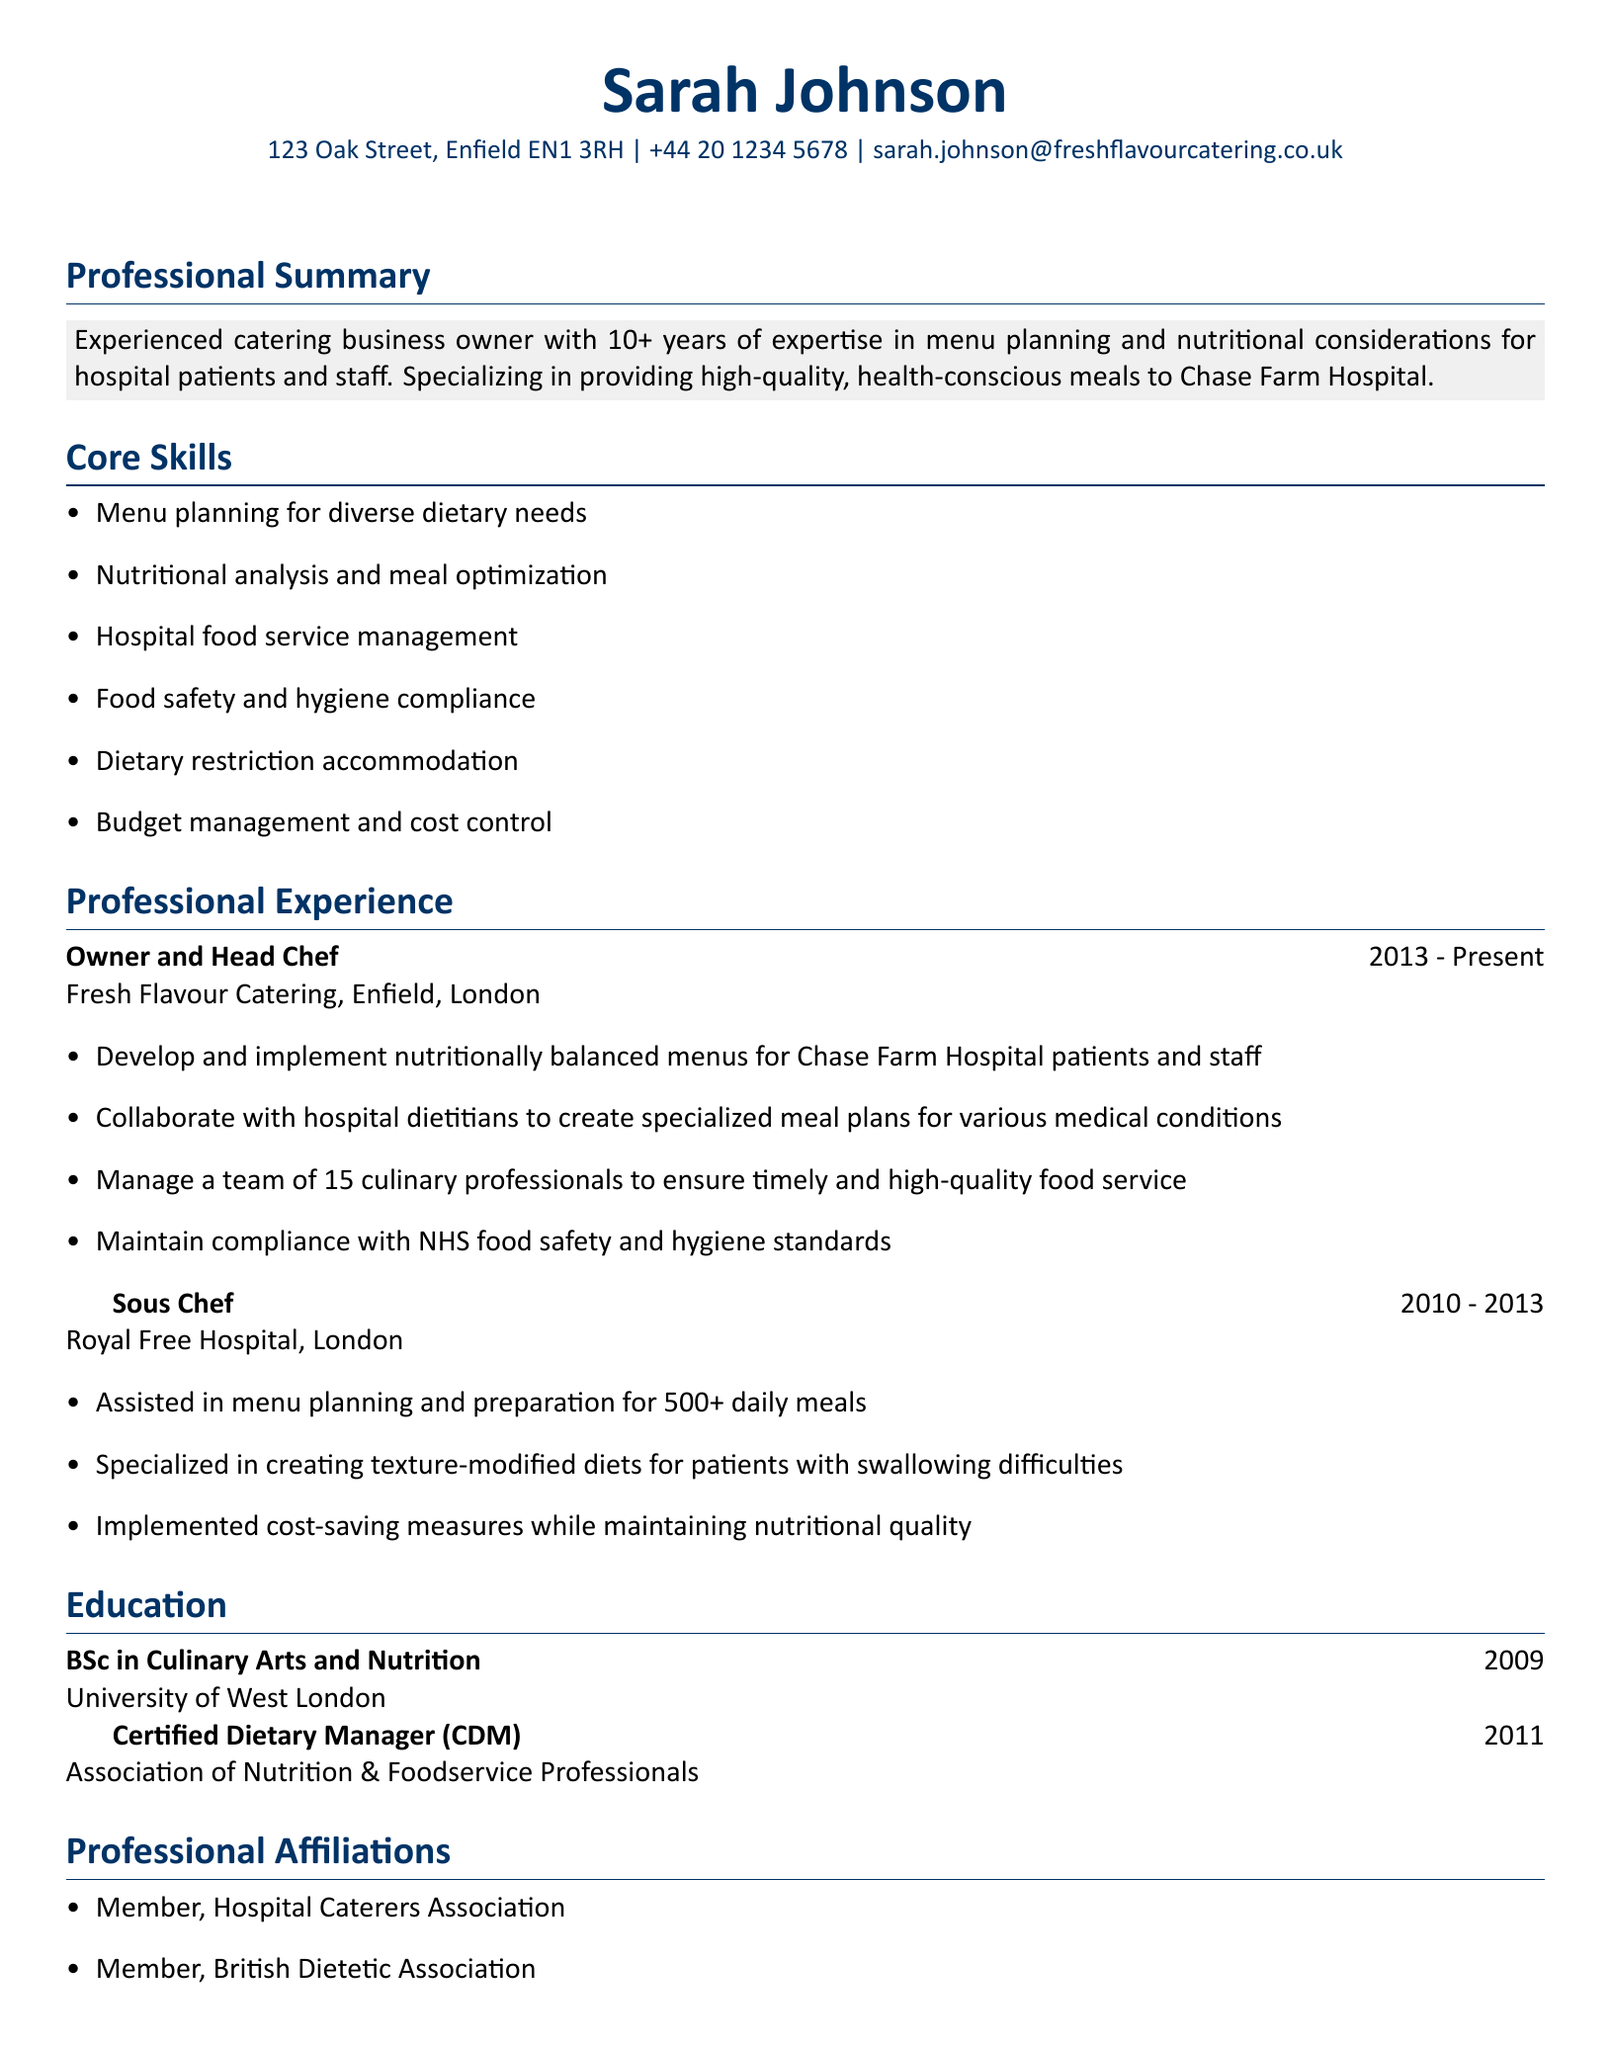What is the name of the business owner? The name of the business owner is listed at the top of the document as Sarah Johnson.
Answer: Sarah Johnson What is Sarah Johnson's email address? The email address is provided in the personal information section of the CV.
Answer: sarah.johnson@freshflavourcatering.co.uk How many years of experience does Sarah Johnson have? The professional summary mentions that she has 10+ years of experience in catering.
Answer: 10+ In which year did Sarah Johnson obtain her degree? The education section states the year she completed her degree in Culinary Arts and Nutrition.
Answer: 2009 What position did Sarah Johnson hold prior to being the Owner and Head Chef? The professional experience section lists her title before her current position.
Answer: Sous Chef How many culinary professionals does Sarah manage? The responsibilities of her current role indicate the number of team members she oversees.
Answer: 15 Which institution issued Sarah Johnson's dietary manager certification? The education section specifies the institution associated with the certification.
Answer: Association of Nutrition & Foodservice Professionals What specialized meal planning does Sarah collaborate on? The document states she works with hospital dietitians on specialized meal plans for various medical conditions.
Answer: Various medical conditions What are the two professional affiliations listed? The professional affiliations section lists the organizations she is a member of.
Answer: Hospital Caterers Association, British Dietetic Association 